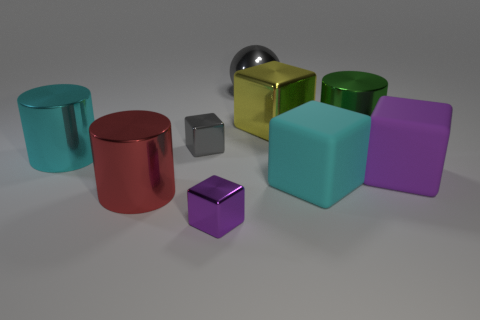There is a block that is behind the green metallic object; is it the same size as the purple cube that is left of the large green metal cylinder?
Provide a short and direct response. No. Are there any other things that have the same material as the large ball?
Offer a very short reply. Yes. The big cyan thing on the left side of the large cyan matte object behind the big object in front of the cyan cube is made of what material?
Keep it short and to the point. Metal. Is the shape of the small gray thing the same as the cyan matte thing?
Your answer should be very brief. Yes. There is another purple thing that is the same shape as the small purple object; what is it made of?
Your answer should be very brief. Rubber. How many big metallic cylinders are the same color as the sphere?
Offer a very short reply. 0. There is a cyan object that is the same material as the large yellow cube; what size is it?
Your answer should be compact. Large. How many brown things are either metallic cylinders or small cubes?
Provide a succinct answer. 0. There is a purple rubber thing right of the red cylinder; what number of cubes are left of it?
Provide a short and direct response. 4. Is the number of big purple rubber objects in front of the large purple block greater than the number of tiny objects behind the small gray cube?
Offer a terse response. No. 